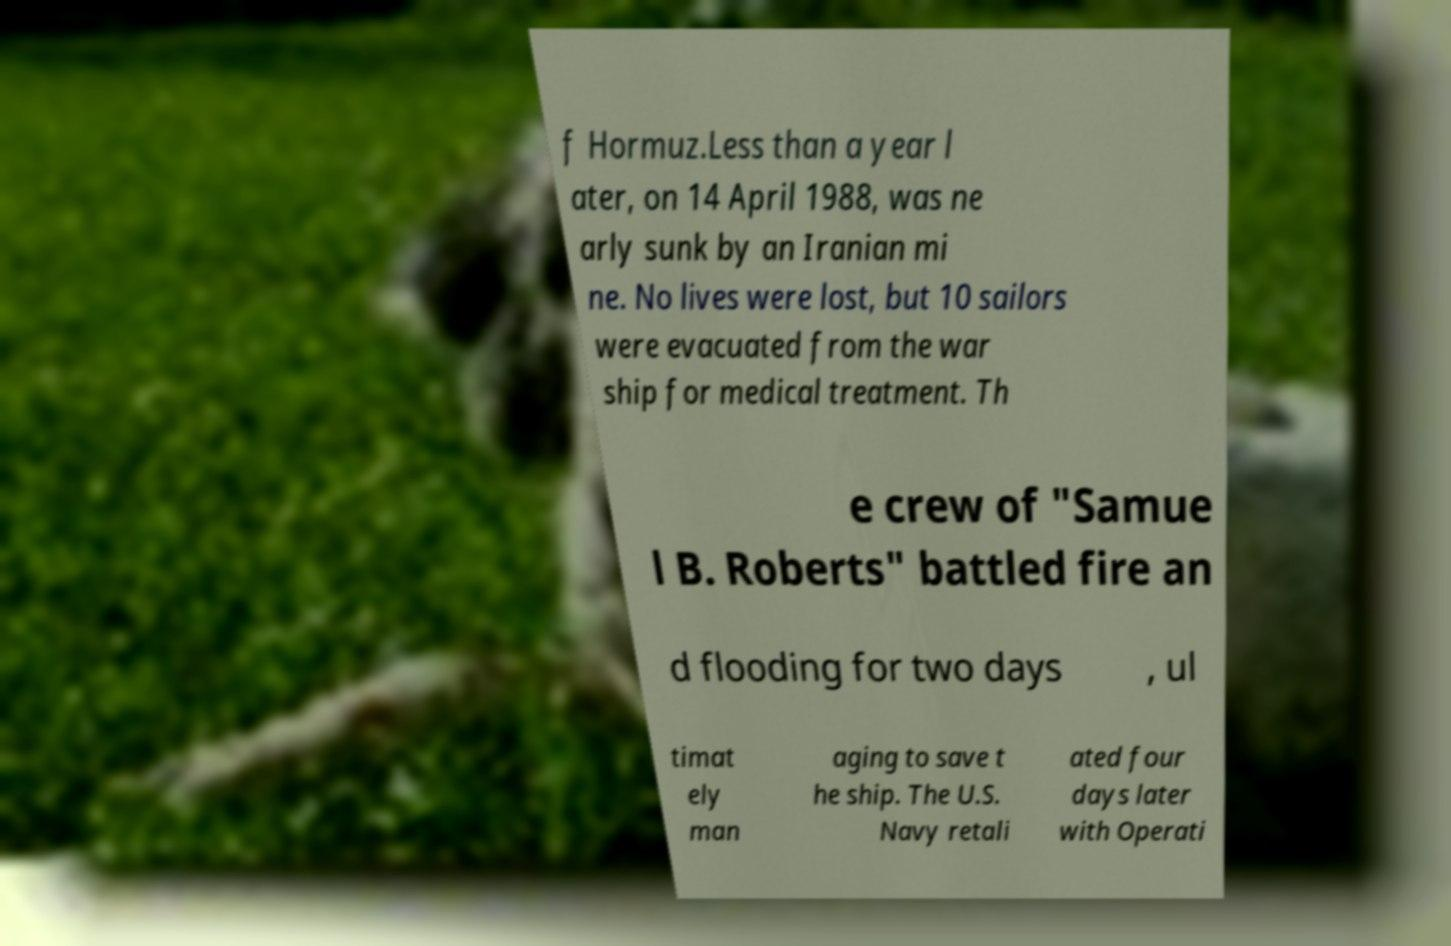Could you extract and type out the text from this image? f Hormuz.Less than a year l ater, on 14 April 1988, was ne arly sunk by an Iranian mi ne. No lives were lost, but 10 sailors were evacuated from the war ship for medical treatment. Th e crew of "Samue l B. Roberts" battled fire an d flooding for two days , ul timat ely man aging to save t he ship. The U.S. Navy retali ated four days later with Operati 